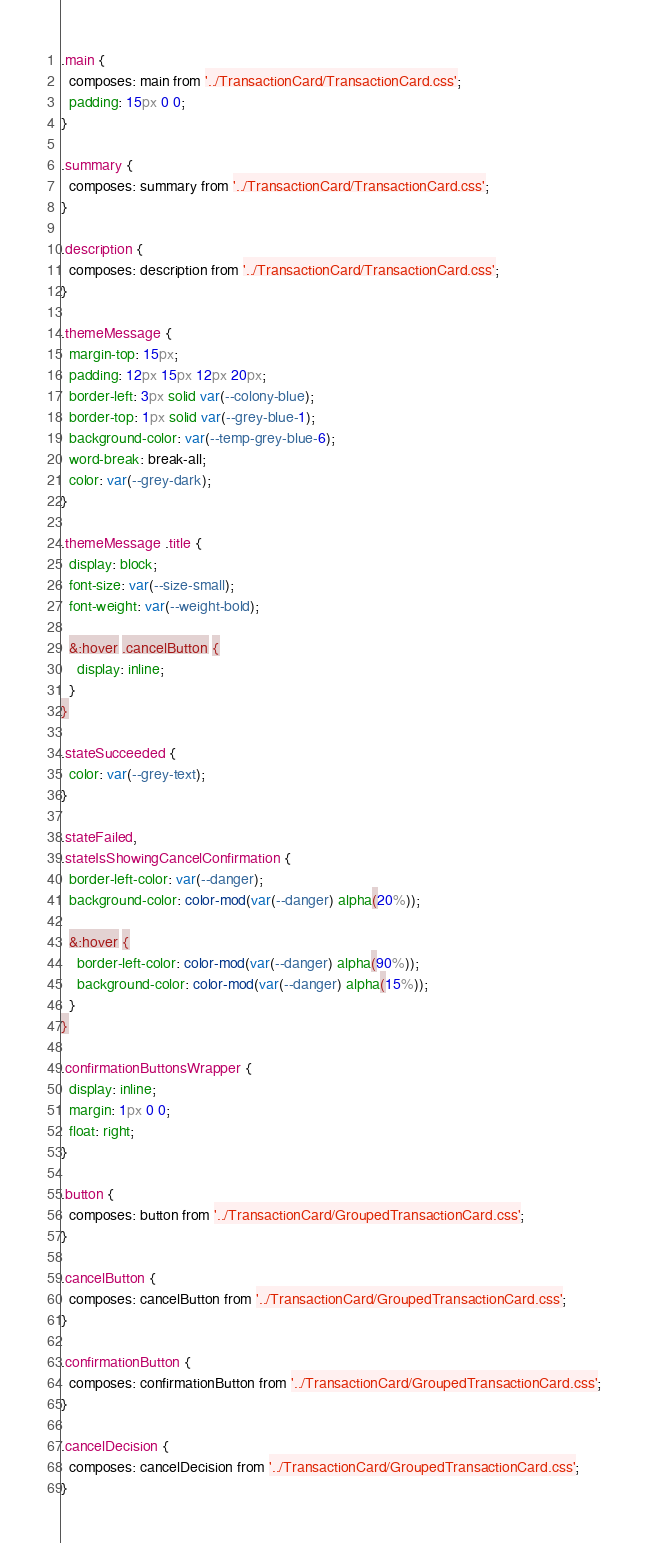<code> <loc_0><loc_0><loc_500><loc_500><_CSS_>.main {
  composes: main from '../TransactionCard/TransactionCard.css';
  padding: 15px 0 0;
}

.summary {
  composes: summary from '../TransactionCard/TransactionCard.css';
}

.description {
  composes: description from '../TransactionCard/TransactionCard.css';
}

.themeMessage {
  margin-top: 15px;
  padding: 12px 15px 12px 20px;
  border-left: 3px solid var(--colony-blue);
  border-top: 1px solid var(--grey-blue-1);
  background-color: var(--temp-grey-blue-6);
  word-break: break-all;
  color: var(--grey-dark);
}

.themeMessage .title {
  display: block;
  font-size: var(--size-small);
  font-weight: var(--weight-bold);

  &:hover .cancelButton {
    display: inline;
  }
}

.stateSucceeded {
  color: var(--grey-text);
}

.stateFailed,
.stateIsShowingCancelConfirmation {
  border-left-color: var(--danger);
  background-color: color-mod(var(--danger) alpha(20%));

  &:hover {
    border-left-color: color-mod(var(--danger) alpha(90%));
    background-color: color-mod(var(--danger) alpha(15%));
  }
}

.confirmationButtonsWrapper {
  display: inline;
  margin: 1px 0 0;
  float: right;
}

.button {
  composes: button from '../TransactionCard/GroupedTransactionCard.css';
}

.cancelButton {
  composes: cancelButton from '../TransactionCard/GroupedTransactionCard.css';
}

.confirmationButton {
  composes: confirmationButton from '../TransactionCard/GroupedTransactionCard.css';
}

.cancelDecision {
  composes: cancelDecision from '../TransactionCard/GroupedTransactionCard.css';
}
</code> 